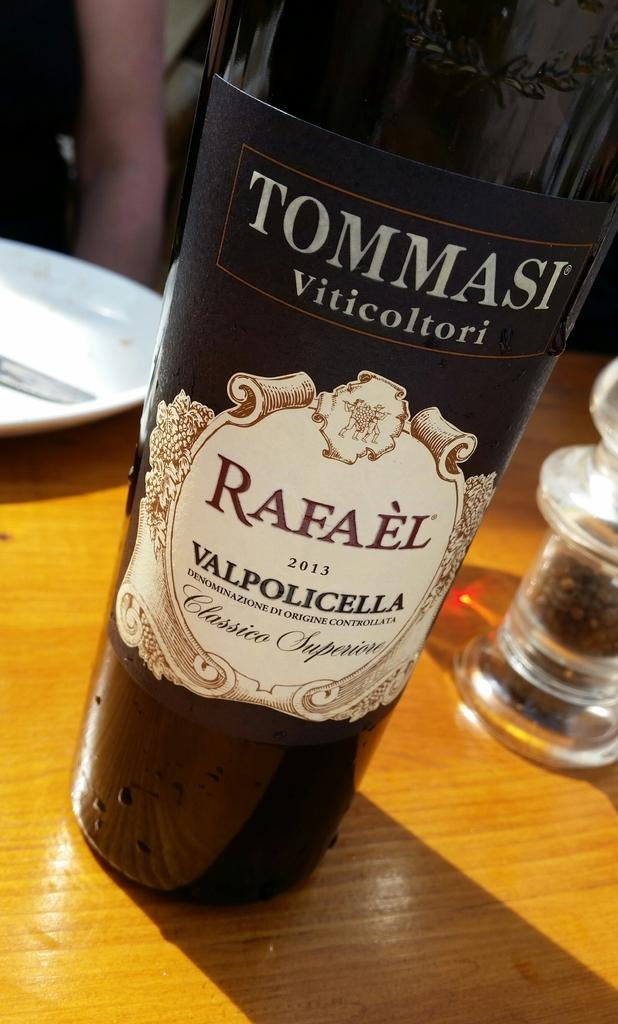<image>
Present a compact description of the photo's key features. A black bottle of Tommasi citicoltori sitting on a wooden table. 